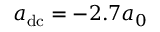Convert formula to latex. <formula><loc_0><loc_0><loc_500><loc_500>a _ { d c } = - 2 . 7 a _ { 0 }</formula> 